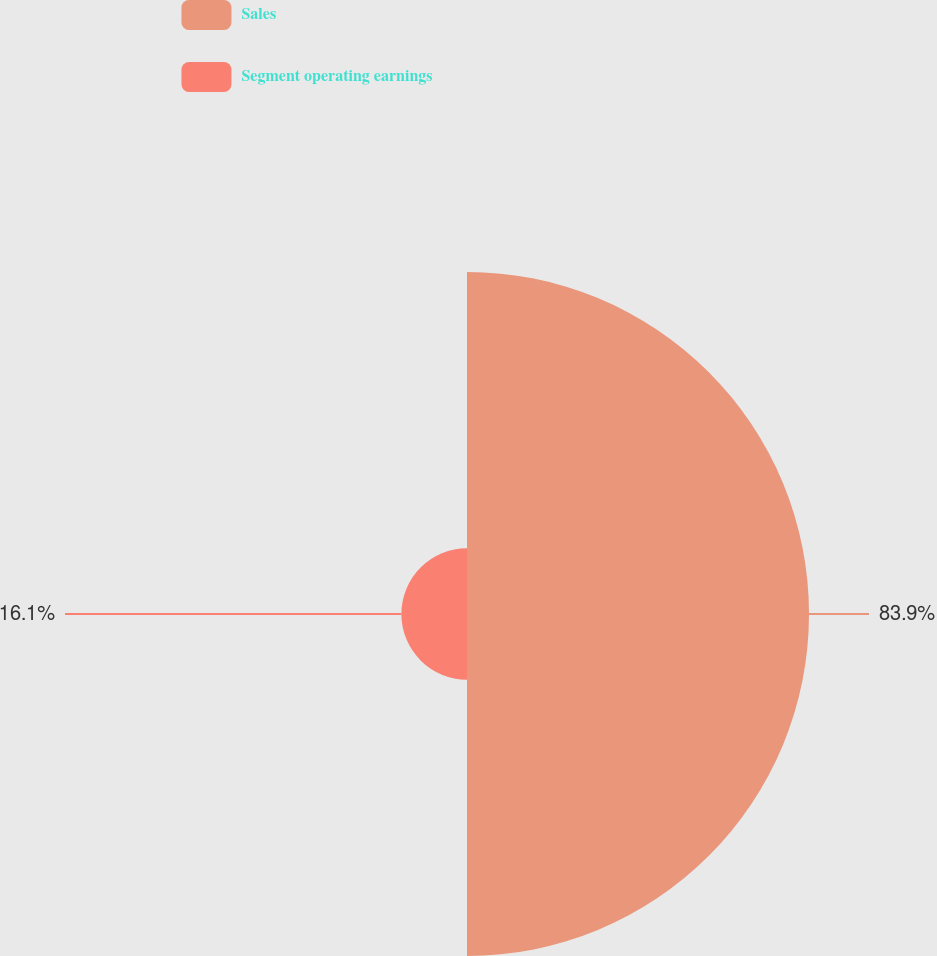Convert chart. <chart><loc_0><loc_0><loc_500><loc_500><pie_chart><fcel>Sales<fcel>Segment operating earnings<nl><fcel>83.9%<fcel>16.1%<nl></chart> 